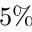<formula> <loc_0><loc_0><loc_500><loc_500>5 \%</formula> 